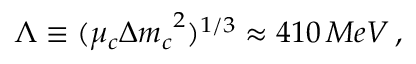<formula> <loc_0><loc_0><loc_500><loc_500>\Lambda \equiv ( \mu _ { c } { \Delta m _ { c } } ^ { 2 } ) ^ { 1 / 3 } \approx 4 1 0 \, M e V \, ,</formula> 